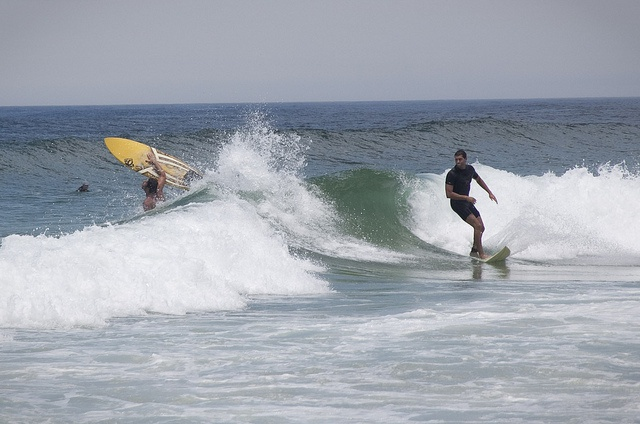Describe the objects in this image and their specific colors. I can see surfboard in darkgray, tan, and gray tones, people in darkgray, black, gray, and lightgray tones, people in darkgray, gray, and black tones, and surfboard in darkgray and gray tones in this image. 